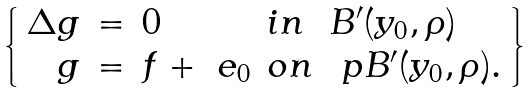Convert formula to latex. <formula><loc_0><loc_0><loc_500><loc_500>\left \{ \begin{array} { r c l l l } \Delta g & = & 0 & i n & B ^ { \prime } ( y _ { 0 } , \rho ) \\ g & = & f + \ e _ { 0 } & o n & \ p B ^ { \prime } ( y _ { 0 } , \rho ) . \end{array} \right \}</formula> 